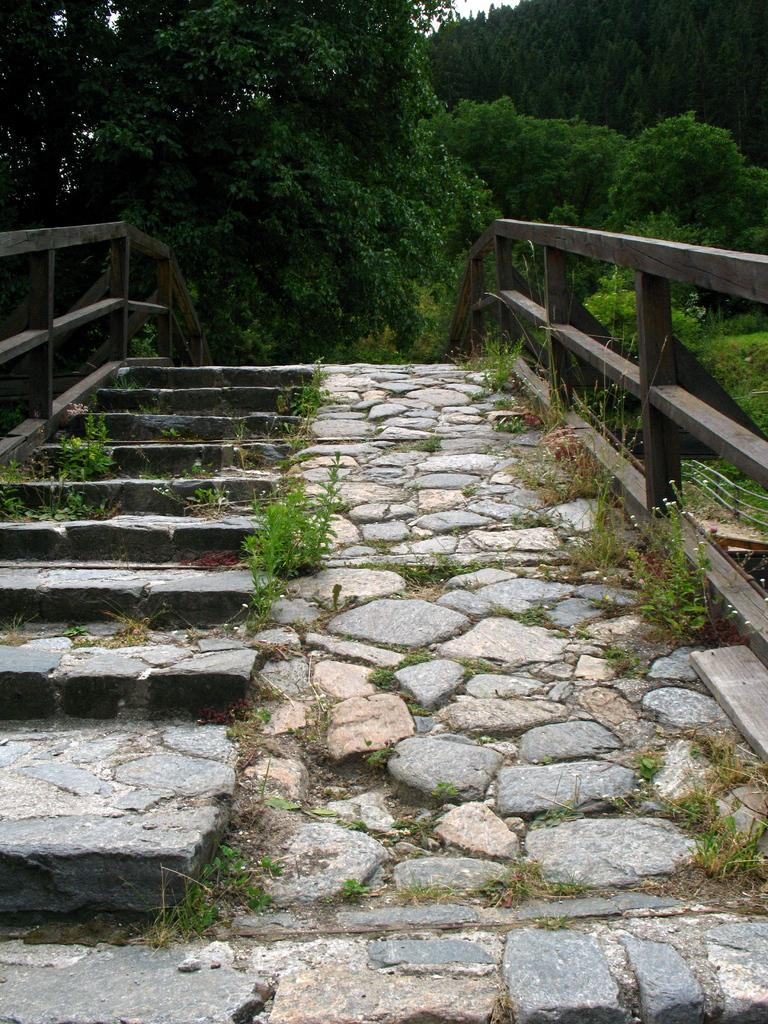What type of natural environment can be seen in the background of the image? There are trees in the background of the image. What celestial objects are visible on the left side of the image? There are stars on the left side of the image. What type of geological formations can be seen in the image? There are rocks visible in the image. Where is the dirt located in the image? There is no dirt present in the image. What type of container is holding the river in the image? There is no jar or river present in the image. 